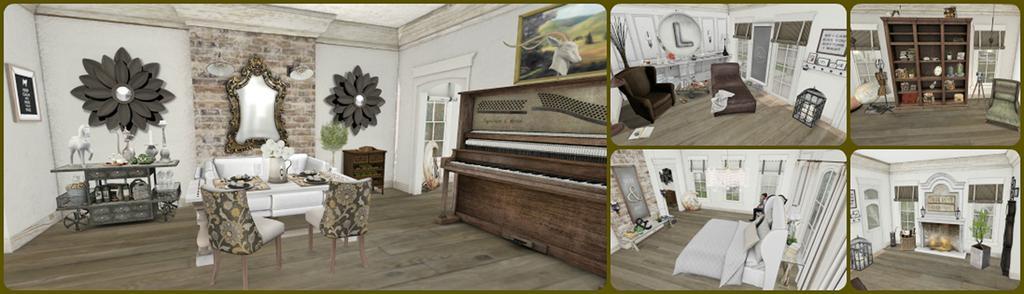Could you give a brief overview of what you see in this image? A collage picture. In this first image we can see piano keyboard, couch, chairs, tables and cupboard. On these tables there is a status and things. Pictures are on the wall. In this second image we can see a bed, decorative item and chair Pictures are on the wall. In this third image we can see a bed with pillows, windows and objects. In this fourth image rack is filled with objects. These are windows and chair. In this fifth image we can see a fireplace, plant, windows and things.   